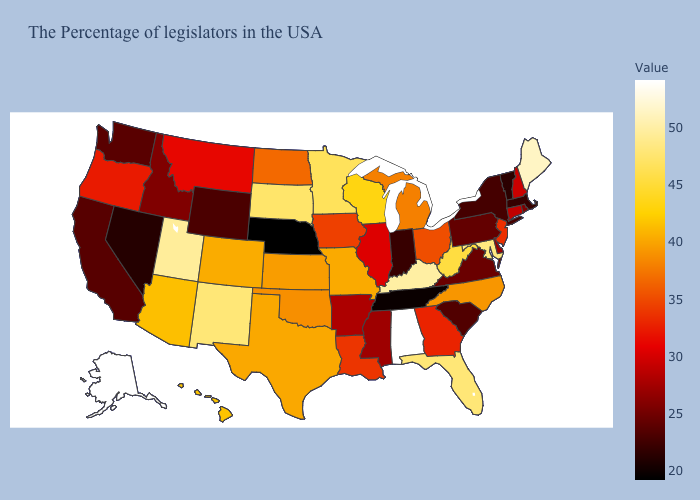Which states have the lowest value in the USA?
Be succinct. Nebraska. Among the states that border Maine , which have the highest value?
Concise answer only. New Hampshire. Among the states that border Delaware , which have the highest value?
Quick response, please. Maryland. Which states have the highest value in the USA?
Short answer required. Alabama, Alaska. Which states have the highest value in the USA?
Keep it brief. Alabama, Alaska. Among the states that border Iowa , which have the lowest value?
Answer briefly. Nebraska. Which states have the lowest value in the Northeast?
Give a very brief answer. Vermont. 